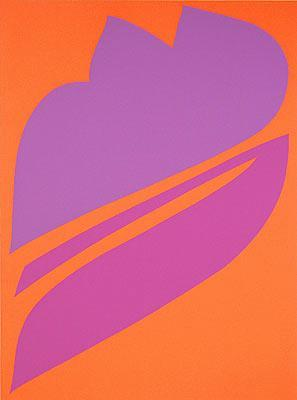What emotions does the color palette in this abstract painting evoke? The bright orange and deep purple used in this painting evoke a sense of vibrancy and drama. Orange often represents energy, enthusiasm, and warmth, while purple can suggest creativity, mystery, and luxury. The combination of these colors may elicit feelings of excitement and contemplative intrigue, pushing the viewer to reflect on the intersecting forms. 